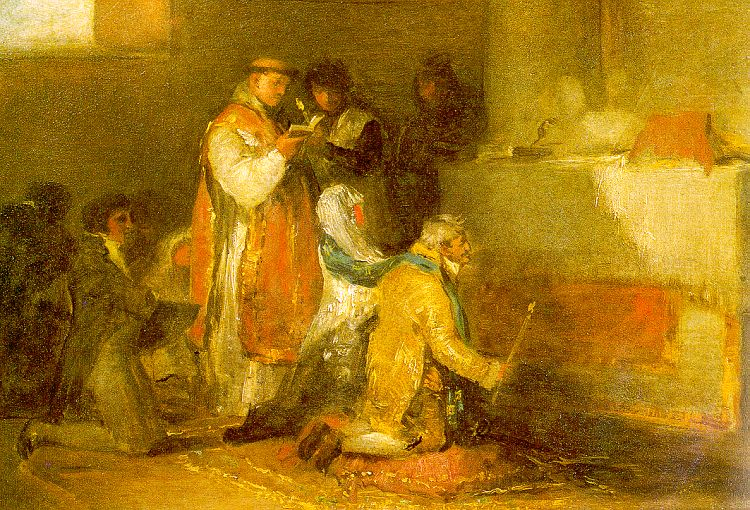Describe a realistic scenario taking place in this image in great detail. A realistic interpretation of this scene could be set in a small, dimly-lit room dedicated to prayer and reflection in a rural 19th-century home. The person in the red robe is likely a local priest or a respected elder, leading a small group of villagers through a daily prayer session. His solemn expression and focused demeanor suggest the gravity of the moment. In the background, a person in a simple blue robe reads along, their posture relaxed but attentive. Next to them, an older man in yellow kneels on a fine rug, hands clasped in focused prayer, possibly seeking solace or forgiveness. The warm tones of the room's dim lighting create a sense of sacred intimacy, highlighting the deep emotional connection between the figures and their faith. 